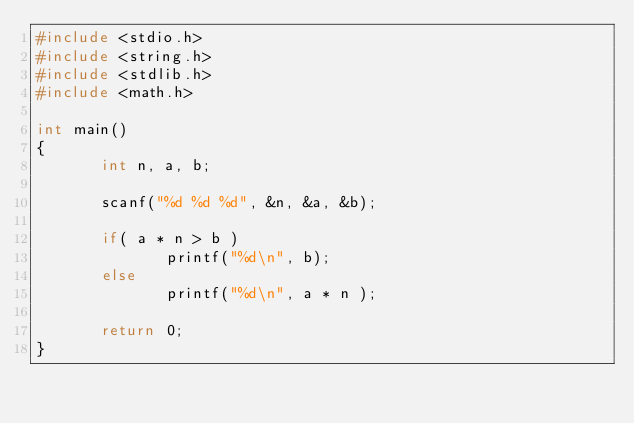<code> <loc_0><loc_0><loc_500><loc_500><_C_>#include <stdio.h>
#include <string.h>
#include <stdlib.h>
#include <math.h>

int main()
{
       int n, a, b;

       scanf("%d %d %d", &n, &a, &b);

       if( a * n > b )
              printf("%d\n", b);
       else
              printf("%d\n", a * n );
      
       return 0;
}</code> 